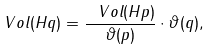<formula> <loc_0><loc_0><loc_500><loc_500>\ V o l ( H q ) = \frac { \ V o l ( H p ) } { \vartheta ( p ) } \cdot \vartheta ( q ) ,</formula> 